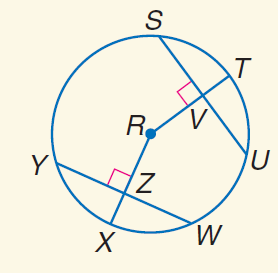Answer the mathemtical geometry problem and directly provide the correct option letter.
Question: In \odot R, S U = 20, Y W = 20, and m \widehat Y X = 45. Find W Z.
Choices: A: 10 B: 20 C: 30 D: 45 A 